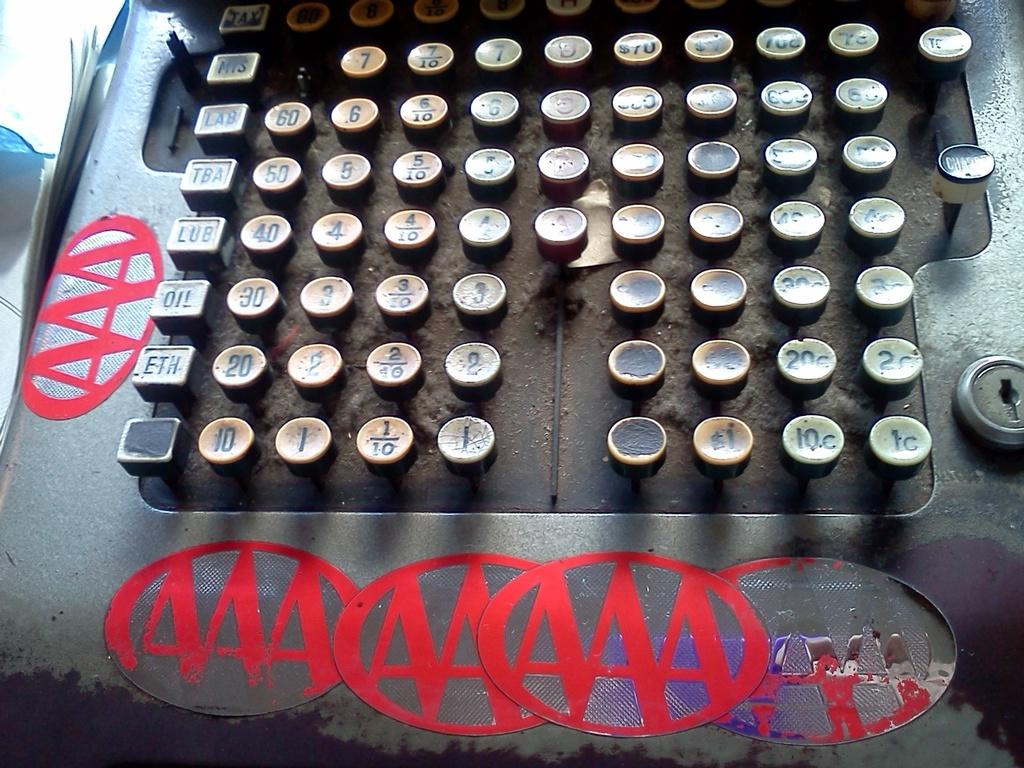<image>
Relay a brief, clear account of the picture shown. A machine with lots of buttons and the AAA logo all over it. 